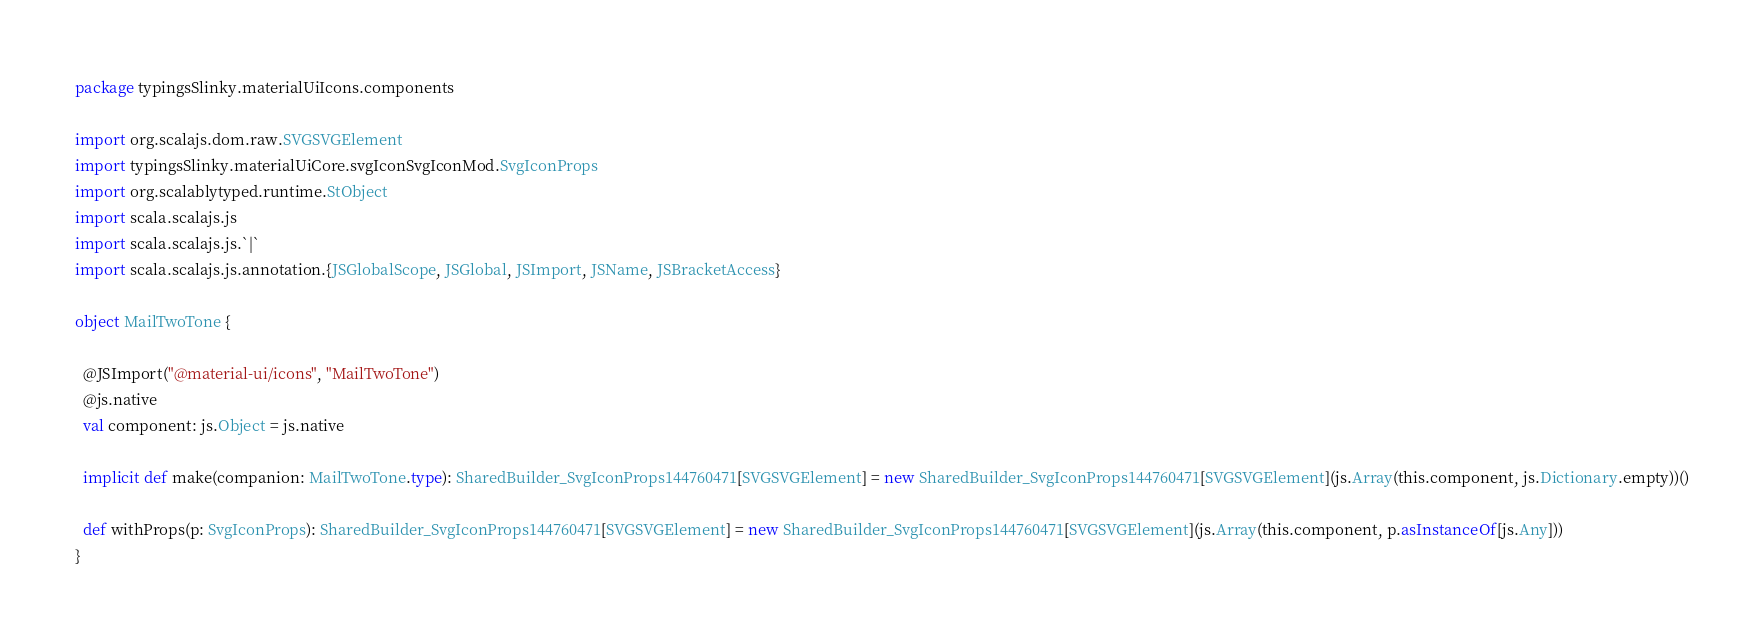<code> <loc_0><loc_0><loc_500><loc_500><_Scala_>package typingsSlinky.materialUiIcons.components

import org.scalajs.dom.raw.SVGSVGElement
import typingsSlinky.materialUiCore.svgIconSvgIconMod.SvgIconProps
import org.scalablytyped.runtime.StObject
import scala.scalajs.js
import scala.scalajs.js.`|`
import scala.scalajs.js.annotation.{JSGlobalScope, JSGlobal, JSImport, JSName, JSBracketAccess}

object MailTwoTone {
  
  @JSImport("@material-ui/icons", "MailTwoTone")
  @js.native
  val component: js.Object = js.native
  
  implicit def make(companion: MailTwoTone.type): SharedBuilder_SvgIconProps144760471[SVGSVGElement] = new SharedBuilder_SvgIconProps144760471[SVGSVGElement](js.Array(this.component, js.Dictionary.empty))()
  
  def withProps(p: SvgIconProps): SharedBuilder_SvgIconProps144760471[SVGSVGElement] = new SharedBuilder_SvgIconProps144760471[SVGSVGElement](js.Array(this.component, p.asInstanceOf[js.Any]))
}
</code> 